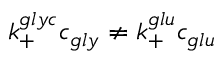<formula> <loc_0><loc_0><loc_500><loc_500>k _ { + } ^ { g l y c } c _ { g l y } \neq k _ { + } ^ { g l u } c _ { g l u }</formula> 